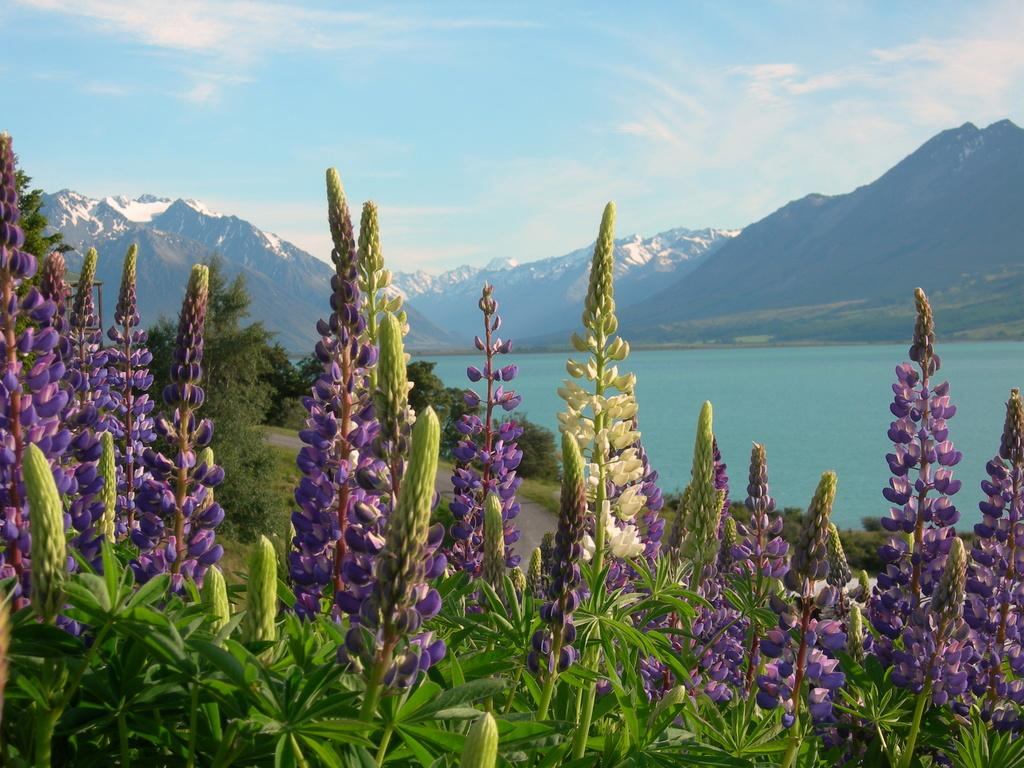What type of flora is present in the image? There are flowers in the image. What colors are the flowers? The flowers are in violet and white colors. What is located in front of the flowers? There are trees in front of the flowers. What can be seen in the distance behind the flowers and trees? There are mountains and water visible in the background of the image. What type of pain is the carriage experiencing in the image? There is no carriage present in the image, so it is not possible to determine if any pain is being experienced. 